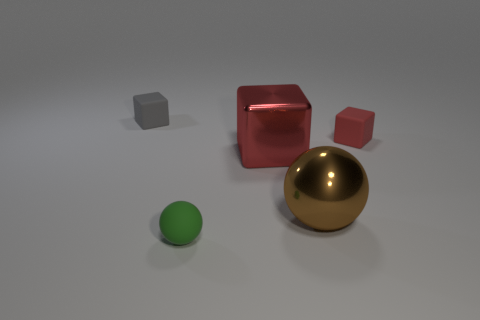Subtract all metal blocks. How many blocks are left? 2 Add 4 large spheres. How many objects exist? 9 Subtract 2 blocks. How many blocks are left? 1 Subtract all green spheres. How many spheres are left? 1 Subtract all spheres. How many objects are left? 3 Subtract all green spheres. Subtract all gray cubes. How many spheres are left? 1 Subtract all yellow blocks. How many gray balls are left? 0 Subtract all cubes. Subtract all cyan shiny spheres. How many objects are left? 2 Add 2 brown objects. How many brown objects are left? 3 Add 5 yellow metallic objects. How many yellow metallic objects exist? 5 